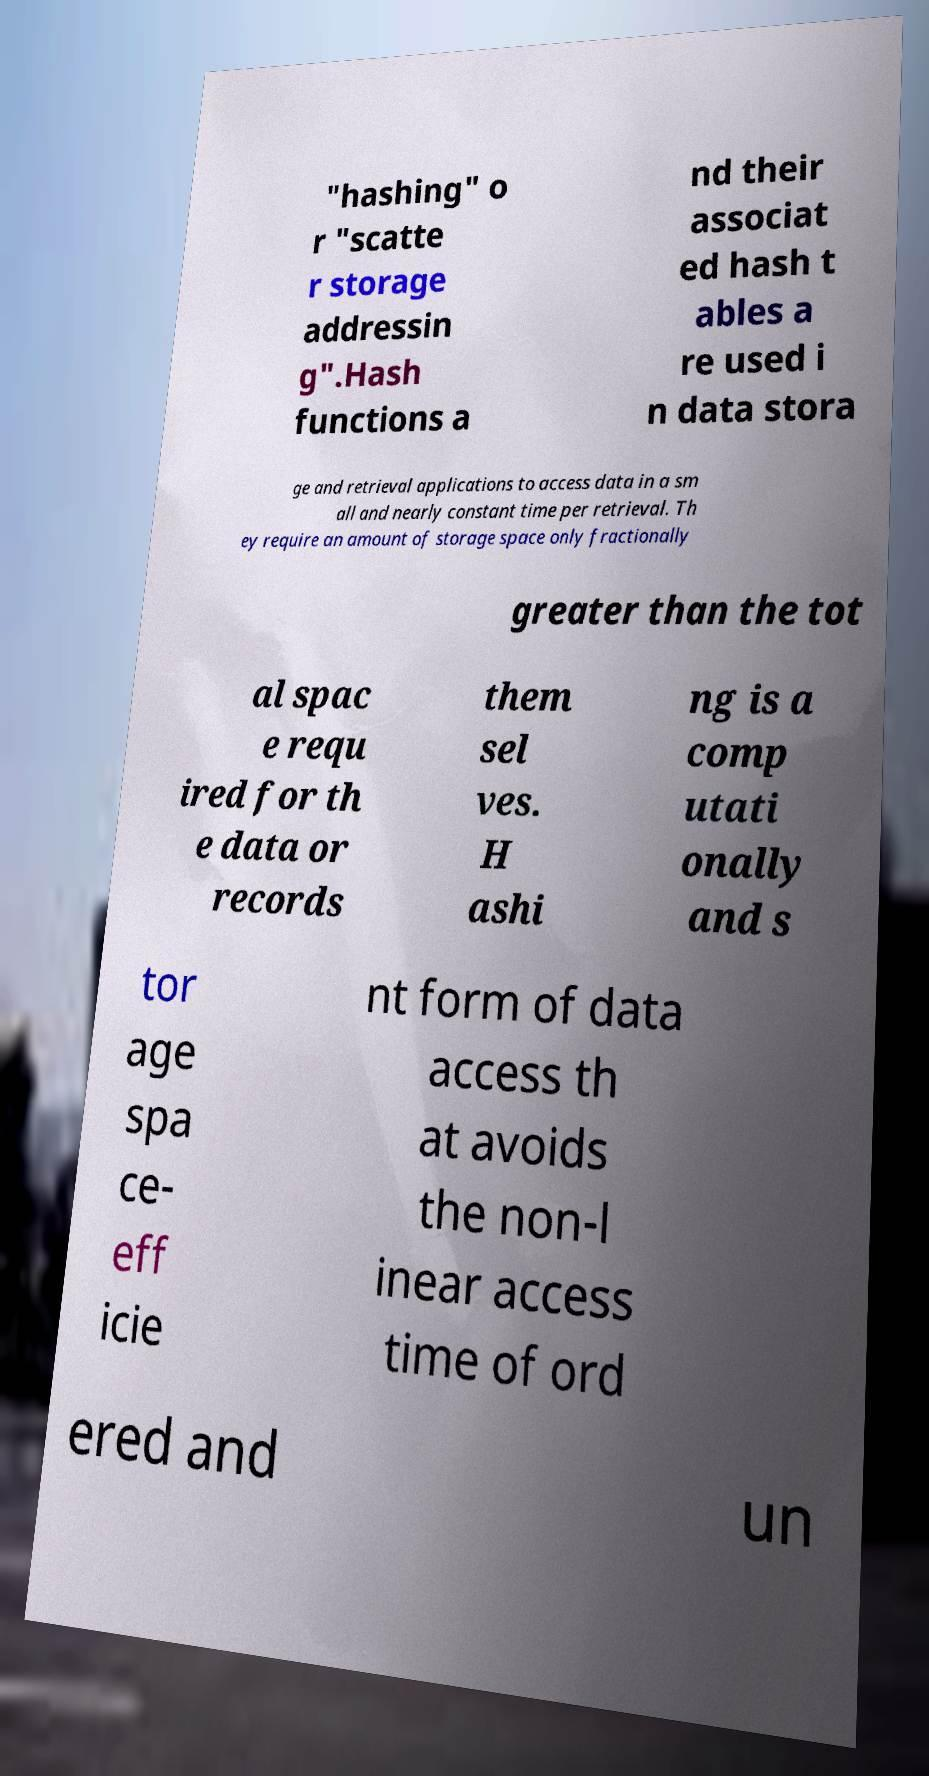Can you read and provide the text displayed in the image?This photo seems to have some interesting text. Can you extract and type it out for me? "hashing" o r "scatte r storage addressin g".Hash functions a nd their associat ed hash t ables a re used i n data stora ge and retrieval applications to access data in a sm all and nearly constant time per retrieval. Th ey require an amount of storage space only fractionally greater than the tot al spac e requ ired for th e data or records them sel ves. H ashi ng is a comp utati onally and s tor age spa ce- eff icie nt form of data access th at avoids the non-l inear access time of ord ered and un 